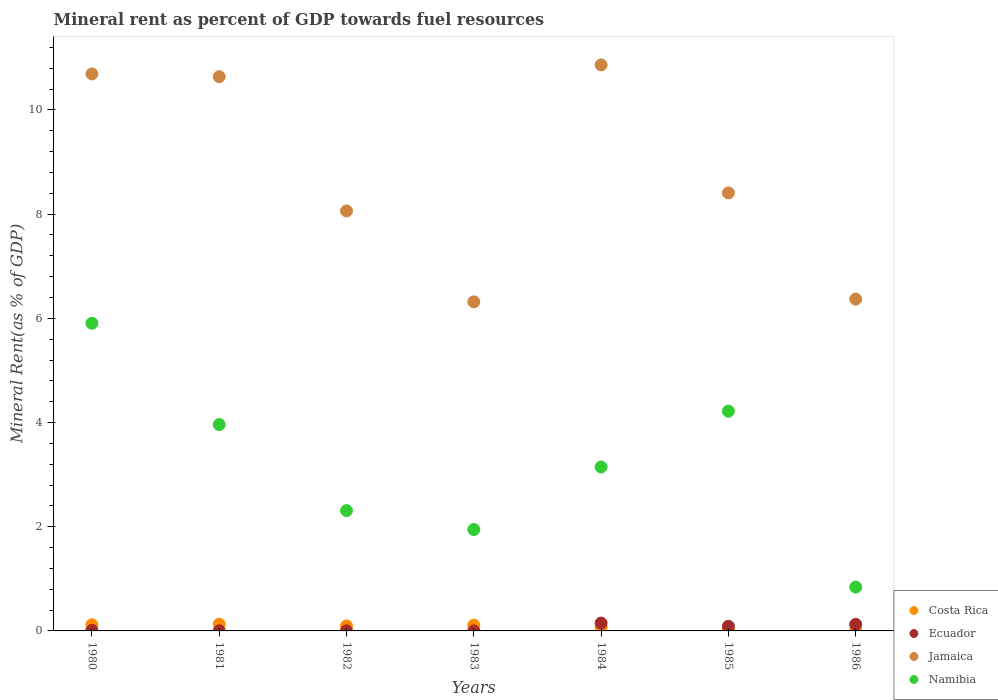Is the number of dotlines equal to the number of legend labels?
Provide a succinct answer. Yes. What is the mineral rent in Jamaica in 1983?
Your answer should be compact. 6.32. Across all years, what is the maximum mineral rent in Jamaica?
Provide a short and direct response. 10.87. Across all years, what is the minimum mineral rent in Namibia?
Keep it short and to the point. 0.84. In which year was the mineral rent in Costa Rica maximum?
Your answer should be very brief. 1981. In which year was the mineral rent in Costa Rica minimum?
Provide a short and direct response. 1985. What is the total mineral rent in Costa Rica in the graph?
Provide a short and direct response. 0.57. What is the difference between the mineral rent in Costa Rica in 1982 and that in 1984?
Provide a succinct answer. 0.03. What is the difference between the mineral rent in Jamaica in 1984 and the mineral rent in Costa Rica in 1982?
Provide a succinct answer. 10.77. What is the average mineral rent in Costa Rica per year?
Your answer should be very brief. 0.08. In the year 1986, what is the difference between the mineral rent in Namibia and mineral rent in Jamaica?
Provide a short and direct response. -5.53. What is the ratio of the mineral rent in Costa Rica in 1980 to that in 1985?
Your answer should be compact. 6.76. Is the mineral rent in Costa Rica in 1980 less than that in 1982?
Provide a succinct answer. No. What is the difference between the highest and the second highest mineral rent in Jamaica?
Your answer should be very brief. 0.17. What is the difference between the highest and the lowest mineral rent in Jamaica?
Your response must be concise. 4.55. In how many years, is the mineral rent in Jamaica greater than the average mineral rent in Jamaica taken over all years?
Your answer should be compact. 3. Is the mineral rent in Ecuador strictly greater than the mineral rent in Namibia over the years?
Give a very brief answer. No. Is the mineral rent in Namibia strictly less than the mineral rent in Costa Rica over the years?
Your answer should be compact. No. What is the difference between two consecutive major ticks on the Y-axis?
Make the answer very short. 2. Are the values on the major ticks of Y-axis written in scientific E-notation?
Give a very brief answer. No. Does the graph contain any zero values?
Offer a terse response. No. Does the graph contain grids?
Offer a very short reply. No. Where does the legend appear in the graph?
Your answer should be compact. Bottom right. How many legend labels are there?
Your answer should be very brief. 4. What is the title of the graph?
Offer a terse response. Mineral rent as percent of GDP towards fuel resources. Does "Togo" appear as one of the legend labels in the graph?
Make the answer very short. No. What is the label or title of the X-axis?
Ensure brevity in your answer.  Years. What is the label or title of the Y-axis?
Your response must be concise. Mineral Rent(as % of GDP). What is the Mineral Rent(as % of GDP) in Costa Rica in 1980?
Ensure brevity in your answer.  0.12. What is the Mineral Rent(as % of GDP) of Ecuador in 1980?
Provide a succinct answer. 0.01. What is the Mineral Rent(as % of GDP) of Jamaica in 1980?
Make the answer very short. 10.69. What is the Mineral Rent(as % of GDP) of Namibia in 1980?
Make the answer very short. 5.91. What is the Mineral Rent(as % of GDP) in Costa Rica in 1981?
Provide a succinct answer. 0.13. What is the Mineral Rent(as % of GDP) in Ecuador in 1981?
Give a very brief answer. 0. What is the Mineral Rent(as % of GDP) of Jamaica in 1981?
Your response must be concise. 10.64. What is the Mineral Rent(as % of GDP) of Namibia in 1981?
Give a very brief answer. 3.96. What is the Mineral Rent(as % of GDP) of Costa Rica in 1982?
Provide a succinct answer. 0.1. What is the Mineral Rent(as % of GDP) of Ecuador in 1982?
Provide a succinct answer. 0. What is the Mineral Rent(as % of GDP) in Jamaica in 1982?
Give a very brief answer. 8.06. What is the Mineral Rent(as % of GDP) in Namibia in 1982?
Ensure brevity in your answer.  2.31. What is the Mineral Rent(as % of GDP) of Costa Rica in 1983?
Your response must be concise. 0.11. What is the Mineral Rent(as % of GDP) of Ecuador in 1983?
Provide a succinct answer. 0. What is the Mineral Rent(as % of GDP) in Jamaica in 1983?
Ensure brevity in your answer.  6.32. What is the Mineral Rent(as % of GDP) of Namibia in 1983?
Ensure brevity in your answer.  1.95. What is the Mineral Rent(as % of GDP) in Costa Rica in 1984?
Keep it short and to the point. 0.07. What is the Mineral Rent(as % of GDP) in Ecuador in 1984?
Your answer should be compact. 0.15. What is the Mineral Rent(as % of GDP) in Jamaica in 1984?
Provide a succinct answer. 10.87. What is the Mineral Rent(as % of GDP) of Namibia in 1984?
Ensure brevity in your answer.  3.15. What is the Mineral Rent(as % of GDP) of Costa Rica in 1985?
Ensure brevity in your answer.  0.02. What is the Mineral Rent(as % of GDP) of Ecuador in 1985?
Provide a succinct answer. 0.09. What is the Mineral Rent(as % of GDP) in Jamaica in 1985?
Your answer should be compact. 8.41. What is the Mineral Rent(as % of GDP) in Namibia in 1985?
Give a very brief answer. 4.22. What is the Mineral Rent(as % of GDP) of Costa Rica in 1986?
Provide a short and direct response. 0.03. What is the Mineral Rent(as % of GDP) in Ecuador in 1986?
Provide a succinct answer. 0.13. What is the Mineral Rent(as % of GDP) of Jamaica in 1986?
Offer a very short reply. 6.37. What is the Mineral Rent(as % of GDP) of Namibia in 1986?
Make the answer very short. 0.84. Across all years, what is the maximum Mineral Rent(as % of GDP) in Costa Rica?
Provide a short and direct response. 0.13. Across all years, what is the maximum Mineral Rent(as % of GDP) of Ecuador?
Offer a terse response. 0.15. Across all years, what is the maximum Mineral Rent(as % of GDP) of Jamaica?
Your response must be concise. 10.87. Across all years, what is the maximum Mineral Rent(as % of GDP) of Namibia?
Provide a short and direct response. 5.91. Across all years, what is the minimum Mineral Rent(as % of GDP) in Costa Rica?
Your answer should be very brief. 0.02. Across all years, what is the minimum Mineral Rent(as % of GDP) in Ecuador?
Your answer should be very brief. 0. Across all years, what is the minimum Mineral Rent(as % of GDP) of Jamaica?
Your response must be concise. 6.32. Across all years, what is the minimum Mineral Rent(as % of GDP) in Namibia?
Make the answer very short. 0.84. What is the total Mineral Rent(as % of GDP) of Costa Rica in the graph?
Your answer should be very brief. 0.57. What is the total Mineral Rent(as % of GDP) of Ecuador in the graph?
Provide a succinct answer. 0.38. What is the total Mineral Rent(as % of GDP) in Jamaica in the graph?
Your answer should be compact. 61.35. What is the total Mineral Rent(as % of GDP) in Namibia in the graph?
Ensure brevity in your answer.  22.33. What is the difference between the Mineral Rent(as % of GDP) of Costa Rica in 1980 and that in 1981?
Make the answer very short. -0.01. What is the difference between the Mineral Rent(as % of GDP) in Ecuador in 1980 and that in 1981?
Provide a short and direct response. 0.01. What is the difference between the Mineral Rent(as % of GDP) in Jamaica in 1980 and that in 1981?
Provide a succinct answer. 0.05. What is the difference between the Mineral Rent(as % of GDP) of Namibia in 1980 and that in 1981?
Keep it short and to the point. 1.94. What is the difference between the Mineral Rent(as % of GDP) in Costa Rica in 1980 and that in 1982?
Your response must be concise. 0.02. What is the difference between the Mineral Rent(as % of GDP) in Ecuador in 1980 and that in 1982?
Your answer should be very brief. 0.01. What is the difference between the Mineral Rent(as % of GDP) of Jamaica in 1980 and that in 1982?
Make the answer very short. 2.63. What is the difference between the Mineral Rent(as % of GDP) of Namibia in 1980 and that in 1982?
Make the answer very short. 3.6. What is the difference between the Mineral Rent(as % of GDP) in Costa Rica in 1980 and that in 1983?
Your answer should be very brief. 0.01. What is the difference between the Mineral Rent(as % of GDP) of Ecuador in 1980 and that in 1983?
Offer a terse response. 0.01. What is the difference between the Mineral Rent(as % of GDP) of Jamaica in 1980 and that in 1983?
Provide a succinct answer. 4.37. What is the difference between the Mineral Rent(as % of GDP) of Namibia in 1980 and that in 1983?
Your answer should be very brief. 3.96. What is the difference between the Mineral Rent(as % of GDP) in Costa Rica in 1980 and that in 1984?
Provide a short and direct response. 0.05. What is the difference between the Mineral Rent(as % of GDP) of Ecuador in 1980 and that in 1984?
Your answer should be very brief. -0.14. What is the difference between the Mineral Rent(as % of GDP) in Jamaica in 1980 and that in 1984?
Provide a succinct answer. -0.17. What is the difference between the Mineral Rent(as % of GDP) in Namibia in 1980 and that in 1984?
Your answer should be very brief. 2.76. What is the difference between the Mineral Rent(as % of GDP) in Costa Rica in 1980 and that in 1985?
Your response must be concise. 0.1. What is the difference between the Mineral Rent(as % of GDP) in Ecuador in 1980 and that in 1985?
Your answer should be compact. -0.08. What is the difference between the Mineral Rent(as % of GDP) of Jamaica in 1980 and that in 1985?
Make the answer very short. 2.28. What is the difference between the Mineral Rent(as % of GDP) in Namibia in 1980 and that in 1985?
Ensure brevity in your answer.  1.69. What is the difference between the Mineral Rent(as % of GDP) in Costa Rica in 1980 and that in 1986?
Provide a succinct answer. 0.09. What is the difference between the Mineral Rent(as % of GDP) of Ecuador in 1980 and that in 1986?
Offer a very short reply. -0.11. What is the difference between the Mineral Rent(as % of GDP) of Jamaica in 1980 and that in 1986?
Your answer should be compact. 4.32. What is the difference between the Mineral Rent(as % of GDP) in Namibia in 1980 and that in 1986?
Provide a succinct answer. 5.06. What is the difference between the Mineral Rent(as % of GDP) of Costa Rica in 1981 and that in 1982?
Your answer should be compact. 0.03. What is the difference between the Mineral Rent(as % of GDP) in Ecuador in 1981 and that in 1982?
Keep it short and to the point. 0. What is the difference between the Mineral Rent(as % of GDP) of Jamaica in 1981 and that in 1982?
Offer a very short reply. 2.58. What is the difference between the Mineral Rent(as % of GDP) in Namibia in 1981 and that in 1982?
Give a very brief answer. 1.65. What is the difference between the Mineral Rent(as % of GDP) of Costa Rica in 1981 and that in 1983?
Provide a short and direct response. 0.02. What is the difference between the Mineral Rent(as % of GDP) of Ecuador in 1981 and that in 1983?
Your response must be concise. 0. What is the difference between the Mineral Rent(as % of GDP) in Jamaica in 1981 and that in 1983?
Ensure brevity in your answer.  4.32. What is the difference between the Mineral Rent(as % of GDP) in Namibia in 1981 and that in 1983?
Your answer should be very brief. 2.02. What is the difference between the Mineral Rent(as % of GDP) of Costa Rica in 1981 and that in 1984?
Your answer should be very brief. 0.06. What is the difference between the Mineral Rent(as % of GDP) of Ecuador in 1981 and that in 1984?
Ensure brevity in your answer.  -0.15. What is the difference between the Mineral Rent(as % of GDP) in Jamaica in 1981 and that in 1984?
Offer a very short reply. -0.23. What is the difference between the Mineral Rent(as % of GDP) of Namibia in 1981 and that in 1984?
Provide a short and direct response. 0.81. What is the difference between the Mineral Rent(as % of GDP) of Costa Rica in 1981 and that in 1985?
Offer a terse response. 0.11. What is the difference between the Mineral Rent(as % of GDP) of Ecuador in 1981 and that in 1985?
Give a very brief answer. -0.09. What is the difference between the Mineral Rent(as % of GDP) in Jamaica in 1981 and that in 1985?
Your answer should be compact. 2.23. What is the difference between the Mineral Rent(as % of GDP) in Namibia in 1981 and that in 1985?
Provide a succinct answer. -0.26. What is the difference between the Mineral Rent(as % of GDP) in Costa Rica in 1981 and that in 1986?
Provide a short and direct response. 0.1. What is the difference between the Mineral Rent(as % of GDP) of Ecuador in 1981 and that in 1986?
Your answer should be compact. -0.12. What is the difference between the Mineral Rent(as % of GDP) of Jamaica in 1981 and that in 1986?
Make the answer very short. 4.27. What is the difference between the Mineral Rent(as % of GDP) in Namibia in 1981 and that in 1986?
Give a very brief answer. 3.12. What is the difference between the Mineral Rent(as % of GDP) in Costa Rica in 1982 and that in 1983?
Keep it short and to the point. -0.01. What is the difference between the Mineral Rent(as % of GDP) in Jamaica in 1982 and that in 1983?
Your answer should be very brief. 1.75. What is the difference between the Mineral Rent(as % of GDP) of Namibia in 1982 and that in 1983?
Provide a succinct answer. 0.36. What is the difference between the Mineral Rent(as % of GDP) of Costa Rica in 1982 and that in 1984?
Make the answer very short. 0.03. What is the difference between the Mineral Rent(as % of GDP) in Ecuador in 1982 and that in 1984?
Provide a succinct answer. -0.15. What is the difference between the Mineral Rent(as % of GDP) of Jamaica in 1982 and that in 1984?
Offer a very short reply. -2.8. What is the difference between the Mineral Rent(as % of GDP) of Namibia in 1982 and that in 1984?
Your response must be concise. -0.84. What is the difference between the Mineral Rent(as % of GDP) in Ecuador in 1982 and that in 1985?
Provide a succinct answer. -0.09. What is the difference between the Mineral Rent(as % of GDP) in Jamaica in 1982 and that in 1985?
Your answer should be compact. -0.35. What is the difference between the Mineral Rent(as % of GDP) in Namibia in 1982 and that in 1985?
Make the answer very short. -1.91. What is the difference between the Mineral Rent(as % of GDP) of Costa Rica in 1982 and that in 1986?
Provide a short and direct response. 0.07. What is the difference between the Mineral Rent(as % of GDP) of Ecuador in 1982 and that in 1986?
Keep it short and to the point. -0.12. What is the difference between the Mineral Rent(as % of GDP) of Jamaica in 1982 and that in 1986?
Your response must be concise. 1.69. What is the difference between the Mineral Rent(as % of GDP) of Namibia in 1982 and that in 1986?
Your response must be concise. 1.47. What is the difference between the Mineral Rent(as % of GDP) of Costa Rica in 1983 and that in 1984?
Keep it short and to the point. 0.04. What is the difference between the Mineral Rent(as % of GDP) of Ecuador in 1983 and that in 1984?
Give a very brief answer. -0.15. What is the difference between the Mineral Rent(as % of GDP) of Jamaica in 1983 and that in 1984?
Offer a terse response. -4.55. What is the difference between the Mineral Rent(as % of GDP) in Namibia in 1983 and that in 1984?
Give a very brief answer. -1.2. What is the difference between the Mineral Rent(as % of GDP) of Costa Rica in 1983 and that in 1985?
Provide a succinct answer. 0.09. What is the difference between the Mineral Rent(as % of GDP) in Ecuador in 1983 and that in 1985?
Your response must be concise. -0.09. What is the difference between the Mineral Rent(as % of GDP) in Jamaica in 1983 and that in 1985?
Give a very brief answer. -2.09. What is the difference between the Mineral Rent(as % of GDP) of Namibia in 1983 and that in 1985?
Your response must be concise. -2.27. What is the difference between the Mineral Rent(as % of GDP) in Costa Rica in 1983 and that in 1986?
Provide a short and direct response. 0.09. What is the difference between the Mineral Rent(as % of GDP) in Ecuador in 1983 and that in 1986?
Your answer should be very brief. -0.13. What is the difference between the Mineral Rent(as % of GDP) of Jamaica in 1983 and that in 1986?
Provide a short and direct response. -0.05. What is the difference between the Mineral Rent(as % of GDP) in Namibia in 1983 and that in 1986?
Your response must be concise. 1.1. What is the difference between the Mineral Rent(as % of GDP) in Costa Rica in 1984 and that in 1985?
Provide a short and direct response. 0.05. What is the difference between the Mineral Rent(as % of GDP) in Ecuador in 1984 and that in 1985?
Give a very brief answer. 0.06. What is the difference between the Mineral Rent(as % of GDP) in Jamaica in 1984 and that in 1985?
Offer a terse response. 2.46. What is the difference between the Mineral Rent(as % of GDP) in Namibia in 1984 and that in 1985?
Your answer should be compact. -1.07. What is the difference between the Mineral Rent(as % of GDP) of Costa Rica in 1984 and that in 1986?
Provide a succinct answer. 0.04. What is the difference between the Mineral Rent(as % of GDP) in Ecuador in 1984 and that in 1986?
Ensure brevity in your answer.  0.02. What is the difference between the Mineral Rent(as % of GDP) of Jamaica in 1984 and that in 1986?
Offer a terse response. 4.5. What is the difference between the Mineral Rent(as % of GDP) of Namibia in 1984 and that in 1986?
Offer a very short reply. 2.31. What is the difference between the Mineral Rent(as % of GDP) in Costa Rica in 1985 and that in 1986?
Your answer should be very brief. -0.01. What is the difference between the Mineral Rent(as % of GDP) of Ecuador in 1985 and that in 1986?
Make the answer very short. -0.04. What is the difference between the Mineral Rent(as % of GDP) of Jamaica in 1985 and that in 1986?
Keep it short and to the point. 2.04. What is the difference between the Mineral Rent(as % of GDP) of Namibia in 1985 and that in 1986?
Ensure brevity in your answer.  3.38. What is the difference between the Mineral Rent(as % of GDP) of Costa Rica in 1980 and the Mineral Rent(as % of GDP) of Ecuador in 1981?
Offer a very short reply. 0.12. What is the difference between the Mineral Rent(as % of GDP) in Costa Rica in 1980 and the Mineral Rent(as % of GDP) in Jamaica in 1981?
Make the answer very short. -10.52. What is the difference between the Mineral Rent(as % of GDP) in Costa Rica in 1980 and the Mineral Rent(as % of GDP) in Namibia in 1981?
Provide a succinct answer. -3.84. What is the difference between the Mineral Rent(as % of GDP) of Ecuador in 1980 and the Mineral Rent(as % of GDP) of Jamaica in 1981?
Make the answer very short. -10.63. What is the difference between the Mineral Rent(as % of GDP) in Ecuador in 1980 and the Mineral Rent(as % of GDP) in Namibia in 1981?
Your answer should be compact. -3.95. What is the difference between the Mineral Rent(as % of GDP) of Jamaica in 1980 and the Mineral Rent(as % of GDP) of Namibia in 1981?
Keep it short and to the point. 6.73. What is the difference between the Mineral Rent(as % of GDP) of Costa Rica in 1980 and the Mineral Rent(as % of GDP) of Ecuador in 1982?
Give a very brief answer. 0.12. What is the difference between the Mineral Rent(as % of GDP) in Costa Rica in 1980 and the Mineral Rent(as % of GDP) in Jamaica in 1982?
Offer a very short reply. -7.94. What is the difference between the Mineral Rent(as % of GDP) of Costa Rica in 1980 and the Mineral Rent(as % of GDP) of Namibia in 1982?
Provide a short and direct response. -2.19. What is the difference between the Mineral Rent(as % of GDP) of Ecuador in 1980 and the Mineral Rent(as % of GDP) of Jamaica in 1982?
Offer a very short reply. -8.05. What is the difference between the Mineral Rent(as % of GDP) of Ecuador in 1980 and the Mineral Rent(as % of GDP) of Namibia in 1982?
Ensure brevity in your answer.  -2.3. What is the difference between the Mineral Rent(as % of GDP) of Jamaica in 1980 and the Mineral Rent(as % of GDP) of Namibia in 1982?
Your answer should be compact. 8.38. What is the difference between the Mineral Rent(as % of GDP) of Costa Rica in 1980 and the Mineral Rent(as % of GDP) of Ecuador in 1983?
Provide a short and direct response. 0.12. What is the difference between the Mineral Rent(as % of GDP) in Costa Rica in 1980 and the Mineral Rent(as % of GDP) in Jamaica in 1983?
Make the answer very short. -6.2. What is the difference between the Mineral Rent(as % of GDP) of Costa Rica in 1980 and the Mineral Rent(as % of GDP) of Namibia in 1983?
Give a very brief answer. -1.83. What is the difference between the Mineral Rent(as % of GDP) of Ecuador in 1980 and the Mineral Rent(as % of GDP) of Jamaica in 1983?
Give a very brief answer. -6.31. What is the difference between the Mineral Rent(as % of GDP) in Ecuador in 1980 and the Mineral Rent(as % of GDP) in Namibia in 1983?
Give a very brief answer. -1.93. What is the difference between the Mineral Rent(as % of GDP) of Jamaica in 1980 and the Mineral Rent(as % of GDP) of Namibia in 1983?
Provide a succinct answer. 8.75. What is the difference between the Mineral Rent(as % of GDP) in Costa Rica in 1980 and the Mineral Rent(as % of GDP) in Ecuador in 1984?
Offer a terse response. -0.03. What is the difference between the Mineral Rent(as % of GDP) in Costa Rica in 1980 and the Mineral Rent(as % of GDP) in Jamaica in 1984?
Provide a succinct answer. -10.75. What is the difference between the Mineral Rent(as % of GDP) in Costa Rica in 1980 and the Mineral Rent(as % of GDP) in Namibia in 1984?
Offer a terse response. -3.03. What is the difference between the Mineral Rent(as % of GDP) in Ecuador in 1980 and the Mineral Rent(as % of GDP) in Jamaica in 1984?
Ensure brevity in your answer.  -10.85. What is the difference between the Mineral Rent(as % of GDP) of Ecuador in 1980 and the Mineral Rent(as % of GDP) of Namibia in 1984?
Make the answer very short. -3.14. What is the difference between the Mineral Rent(as % of GDP) of Jamaica in 1980 and the Mineral Rent(as % of GDP) of Namibia in 1984?
Give a very brief answer. 7.54. What is the difference between the Mineral Rent(as % of GDP) of Costa Rica in 1980 and the Mineral Rent(as % of GDP) of Ecuador in 1985?
Offer a very short reply. 0.03. What is the difference between the Mineral Rent(as % of GDP) of Costa Rica in 1980 and the Mineral Rent(as % of GDP) of Jamaica in 1985?
Your answer should be very brief. -8.29. What is the difference between the Mineral Rent(as % of GDP) of Costa Rica in 1980 and the Mineral Rent(as % of GDP) of Namibia in 1985?
Offer a very short reply. -4.1. What is the difference between the Mineral Rent(as % of GDP) in Ecuador in 1980 and the Mineral Rent(as % of GDP) in Jamaica in 1985?
Provide a succinct answer. -8.4. What is the difference between the Mineral Rent(as % of GDP) of Ecuador in 1980 and the Mineral Rent(as % of GDP) of Namibia in 1985?
Provide a succinct answer. -4.21. What is the difference between the Mineral Rent(as % of GDP) in Jamaica in 1980 and the Mineral Rent(as % of GDP) in Namibia in 1985?
Your answer should be very brief. 6.47. What is the difference between the Mineral Rent(as % of GDP) of Costa Rica in 1980 and the Mineral Rent(as % of GDP) of Ecuador in 1986?
Ensure brevity in your answer.  -0.01. What is the difference between the Mineral Rent(as % of GDP) of Costa Rica in 1980 and the Mineral Rent(as % of GDP) of Jamaica in 1986?
Give a very brief answer. -6.25. What is the difference between the Mineral Rent(as % of GDP) in Costa Rica in 1980 and the Mineral Rent(as % of GDP) in Namibia in 1986?
Your response must be concise. -0.72. What is the difference between the Mineral Rent(as % of GDP) of Ecuador in 1980 and the Mineral Rent(as % of GDP) of Jamaica in 1986?
Provide a succinct answer. -6.36. What is the difference between the Mineral Rent(as % of GDP) in Ecuador in 1980 and the Mineral Rent(as % of GDP) in Namibia in 1986?
Keep it short and to the point. -0.83. What is the difference between the Mineral Rent(as % of GDP) of Jamaica in 1980 and the Mineral Rent(as % of GDP) of Namibia in 1986?
Provide a succinct answer. 9.85. What is the difference between the Mineral Rent(as % of GDP) of Costa Rica in 1981 and the Mineral Rent(as % of GDP) of Ecuador in 1982?
Provide a succinct answer. 0.13. What is the difference between the Mineral Rent(as % of GDP) in Costa Rica in 1981 and the Mineral Rent(as % of GDP) in Jamaica in 1982?
Ensure brevity in your answer.  -7.93. What is the difference between the Mineral Rent(as % of GDP) of Costa Rica in 1981 and the Mineral Rent(as % of GDP) of Namibia in 1982?
Provide a succinct answer. -2.18. What is the difference between the Mineral Rent(as % of GDP) of Ecuador in 1981 and the Mineral Rent(as % of GDP) of Jamaica in 1982?
Keep it short and to the point. -8.06. What is the difference between the Mineral Rent(as % of GDP) in Ecuador in 1981 and the Mineral Rent(as % of GDP) in Namibia in 1982?
Your answer should be compact. -2.31. What is the difference between the Mineral Rent(as % of GDP) in Jamaica in 1981 and the Mineral Rent(as % of GDP) in Namibia in 1982?
Offer a very short reply. 8.33. What is the difference between the Mineral Rent(as % of GDP) in Costa Rica in 1981 and the Mineral Rent(as % of GDP) in Ecuador in 1983?
Provide a succinct answer. 0.13. What is the difference between the Mineral Rent(as % of GDP) in Costa Rica in 1981 and the Mineral Rent(as % of GDP) in Jamaica in 1983?
Your answer should be compact. -6.19. What is the difference between the Mineral Rent(as % of GDP) of Costa Rica in 1981 and the Mineral Rent(as % of GDP) of Namibia in 1983?
Make the answer very short. -1.82. What is the difference between the Mineral Rent(as % of GDP) of Ecuador in 1981 and the Mineral Rent(as % of GDP) of Jamaica in 1983?
Provide a succinct answer. -6.31. What is the difference between the Mineral Rent(as % of GDP) in Ecuador in 1981 and the Mineral Rent(as % of GDP) in Namibia in 1983?
Offer a terse response. -1.94. What is the difference between the Mineral Rent(as % of GDP) in Jamaica in 1981 and the Mineral Rent(as % of GDP) in Namibia in 1983?
Offer a very short reply. 8.69. What is the difference between the Mineral Rent(as % of GDP) in Costa Rica in 1981 and the Mineral Rent(as % of GDP) in Ecuador in 1984?
Make the answer very short. -0.02. What is the difference between the Mineral Rent(as % of GDP) in Costa Rica in 1981 and the Mineral Rent(as % of GDP) in Jamaica in 1984?
Offer a terse response. -10.74. What is the difference between the Mineral Rent(as % of GDP) in Costa Rica in 1981 and the Mineral Rent(as % of GDP) in Namibia in 1984?
Give a very brief answer. -3.02. What is the difference between the Mineral Rent(as % of GDP) of Ecuador in 1981 and the Mineral Rent(as % of GDP) of Jamaica in 1984?
Provide a short and direct response. -10.86. What is the difference between the Mineral Rent(as % of GDP) in Ecuador in 1981 and the Mineral Rent(as % of GDP) in Namibia in 1984?
Provide a short and direct response. -3.14. What is the difference between the Mineral Rent(as % of GDP) in Jamaica in 1981 and the Mineral Rent(as % of GDP) in Namibia in 1984?
Give a very brief answer. 7.49. What is the difference between the Mineral Rent(as % of GDP) of Costa Rica in 1981 and the Mineral Rent(as % of GDP) of Ecuador in 1985?
Offer a very short reply. 0.04. What is the difference between the Mineral Rent(as % of GDP) in Costa Rica in 1981 and the Mineral Rent(as % of GDP) in Jamaica in 1985?
Ensure brevity in your answer.  -8.28. What is the difference between the Mineral Rent(as % of GDP) of Costa Rica in 1981 and the Mineral Rent(as % of GDP) of Namibia in 1985?
Provide a succinct answer. -4.09. What is the difference between the Mineral Rent(as % of GDP) in Ecuador in 1981 and the Mineral Rent(as % of GDP) in Jamaica in 1985?
Offer a terse response. -8.4. What is the difference between the Mineral Rent(as % of GDP) in Ecuador in 1981 and the Mineral Rent(as % of GDP) in Namibia in 1985?
Make the answer very short. -4.21. What is the difference between the Mineral Rent(as % of GDP) of Jamaica in 1981 and the Mineral Rent(as % of GDP) of Namibia in 1985?
Keep it short and to the point. 6.42. What is the difference between the Mineral Rent(as % of GDP) in Costa Rica in 1981 and the Mineral Rent(as % of GDP) in Ecuador in 1986?
Provide a short and direct response. 0. What is the difference between the Mineral Rent(as % of GDP) in Costa Rica in 1981 and the Mineral Rent(as % of GDP) in Jamaica in 1986?
Make the answer very short. -6.24. What is the difference between the Mineral Rent(as % of GDP) in Costa Rica in 1981 and the Mineral Rent(as % of GDP) in Namibia in 1986?
Give a very brief answer. -0.71. What is the difference between the Mineral Rent(as % of GDP) of Ecuador in 1981 and the Mineral Rent(as % of GDP) of Jamaica in 1986?
Provide a succinct answer. -6.37. What is the difference between the Mineral Rent(as % of GDP) of Ecuador in 1981 and the Mineral Rent(as % of GDP) of Namibia in 1986?
Offer a terse response. -0.84. What is the difference between the Mineral Rent(as % of GDP) in Jamaica in 1981 and the Mineral Rent(as % of GDP) in Namibia in 1986?
Give a very brief answer. 9.8. What is the difference between the Mineral Rent(as % of GDP) in Costa Rica in 1982 and the Mineral Rent(as % of GDP) in Ecuador in 1983?
Provide a short and direct response. 0.1. What is the difference between the Mineral Rent(as % of GDP) in Costa Rica in 1982 and the Mineral Rent(as % of GDP) in Jamaica in 1983?
Give a very brief answer. -6.22. What is the difference between the Mineral Rent(as % of GDP) of Costa Rica in 1982 and the Mineral Rent(as % of GDP) of Namibia in 1983?
Your answer should be compact. -1.85. What is the difference between the Mineral Rent(as % of GDP) in Ecuador in 1982 and the Mineral Rent(as % of GDP) in Jamaica in 1983?
Make the answer very short. -6.32. What is the difference between the Mineral Rent(as % of GDP) in Ecuador in 1982 and the Mineral Rent(as % of GDP) in Namibia in 1983?
Your response must be concise. -1.94. What is the difference between the Mineral Rent(as % of GDP) in Jamaica in 1982 and the Mineral Rent(as % of GDP) in Namibia in 1983?
Give a very brief answer. 6.12. What is the difference between the Mineral Rent(as % of GDP) of Costa Rica in 1982 and the Mineral Rent(as % of GDP) of Ecuador in 1984?
Keep it short and to the point. -0.05. What is the difference between the Mineral Rent(as % of GDP) in Costa Rica in 1982 and the Mineral Rent(as % of GDP) in Jamaica in 1984?
Provide a short and direct response. -10.77. What is the difference between the Mineral Rent(as % of GDP) in Costa Rica in 1982 and the Mineral Rent(as % of GDP) in Namibia in 1984?
Make the answer very short. -3.05. What is the difference between the Mineral Rent(as % of GDP) in Ecuador in 1982 and the Mineral Rent(as % of GDP) in Jamaica in 1984?
Provide a succinct answer. -10.86. What is the difference between the Mineral Rent(as % of GDP) of Ecuador in 1982 and the Mineral Rent(as % of GDP) of Namibia in 1984?
Your response must be concise. -3.15. What is the difference between the Mineral Rent(as % of GDP) of Jamaica in 1982 and the Mineral Rent(as % of GDP) of Namibia in 1984?
Provide a short and direct response. 4.92. What is the difference between the Mineral Rent(as % of GDP) of Costa Rica in 1982 and the Mineral Rent(as % of GDP) of Ecuador in 1985?
Offer a terse response. 0.01. What is the difference between the Mineral Rent(as % of GDP) in Costa Rica in 1982 and the Mineral Rent(as % of GDP) in Jamaica in 1985?
Your response must be concise. -8.31. What is the difference between the Mineral Rent(as % of GDP) in Costa Rica in 1982 and the Mineral Rent(as % of GDP) in Namibia in 1985?
Provide a succinct answer. -4.12. What is the difference between the Mineral Rent(as % of GDP) in Ecuador in 1982 and the Mineral Rent(as % of GDP) in Jamaica in 1985?
Provide a short and direct response. -8.41. What is the difference between the Mineral Rent(as % of GDP) in Ecuador in 1982 and the Mineral Rent(as % of GDP) in Namibia in 1985?
Your answer should be very brief. -4.22. What is the difference between the Mineral Rent(as % of GDP) in Jamaica in 1982 and the Mineral Rent(as % of GDP) in Namibia in 1985?
Offer a terse response. 3.84. What is the difference between the Mineral Rent(as % of GDP) in Costa Rica in 1982 and the Mineral Rent(as % of GDP) in Ecuador in 1986?
Provide a short and direct response. -0.03. What is the difference between the Mineral Rent(as % of GDP) in Costa Rica in 1982 and the Mineral Rent(as % of GDP) in Jamaica in 1986?
Offer a terse response. -6.27. What is the difference between the Mineral Rent(as % of GDP) in Costa Rica in 1982 and the Mineral Rent(as % of GDP) in Namibia in 1986?
Provide a succinct answer. -0.74. What is the difference between the Mineral Rent(as % of GDP) of Ecuador in 1982 and the Mineral Rent(as % of GDP) of Jamaica in 1986?
Your response must be concise. -6.37. What is the difference between the Mineral Rent(as % of GDP) in Ecuador in 1982 and the Mineral Rent(as % of GDP) in Namibia in 1986?
Provide a succinct answer. -0.84. What is the difference between the Mineral Rent(as % of GDP) of Jamaica in 1982 and the Mineral Rent(as % of GDP) of Namibia in 1986?
Give a very brief answer. 7.22. What is the difference between the Mineral Rent(as % of GDP) in Costa Rica in 1983 and the Mineral Rent(as % of GDP) in Ecuador in 1984?
Keep it short and to the point. -0.04. What is the difference between the Mineral Rent(as % of GDP) of Costa Rica in 1983 and the Mineral Rent(as % of GDP) of Jamaica in 1984?
Offer a terse response. -10.75. What is the difference between the Mineral Rent(as % of GDP) in Costa Rica in 1983 and the Mineral Rent(as % of GDP) in Namibia in 1984?
Provide a short and direct response. -3.03. What is the difference between the Mineral Rent(as % of GDP) in Ecuador in 1983 and the Mineral Rent(as % of GDP) in Jamaica in 1984?
Provide a succinct answer. -10.86. What is the difference between the Mineral Rent(as % of GDP) of Ecuador in 1983 and the Mineral Rent(as % of GDP) of Namibia in 1984?
Make the answer very short. -3.15. What is the difference between the Mineral Rent(as % of GDP) of Jamaica in 1983 and the Mineral Rent(as % of GDP) of Namibia in 1984?
Provide a short and direct response. 3.17. What is the difference between the Mineral Rent(as % of GDP) of Costa Rica in 1983 and the Mineral Rent(as % of GDP) of Ecuador in 1985?
Provide a short and direct response. 0.02. What is the difference between the Mineral Rent(as % of GDP) in Costa Rica in 1983 and the Mineral Rent(as % of GDP) in Jamaica in 1985?
Provide a succinct answer. -8.3. What is the difference between the Mineral Rent(as % of GDP) in Costa Rica in 1983 and the Mineral Rent(as % of GDP) in Namibia in 1985?
Offer a terse response. -4.11. What is the difference between the Mineral Rent(as % of GDP) in Ecuador in 1983 and the Mineral Rent(as % of GDP) in Jamaica in 1985?
Your answer should be very brief. -8.41. What is the difference between the Mineral Rent(as % of GDP) of Ecuador in 1983 and the Mineral Rent(as % of GDP) of Namibia in 1985?
Give a very brief answer. -4.22. What is the difference between the Mineral Rent(as % of GDP) of Jamaica in 1983 and the Mineral Rent(as % of GDP) of Namibia in 1985?
Give a very brief answer. 2.1. What is the difference between the Mineral Rent(as % of GDP) in Costa Rica in 1983 and the Mineral Rent(as % of GDP) in Ecuador in 1986?
Give a very brief answer. -0.01. What is the difference between the Mineral Rent(as % of GDP) in Costa Rica in 1983 and the Mineral Rent(as % of GDP) in Jamaica in 1986?
Your answer should be compact. -6.26. What is the difference between the Mineral Rent(as % of GDP) in Costa Rica in 1983 and the Mineral Rent(as % of GDP) in Namibia in 1986?
Offer a terse response. -0.73. What is the difference between the Mineral Rent(as % of GDP) in Ecuador in 1983 and the Mineral Rent(as % of GDP) in Jamaica in 1986?
Offer a very short reply. -6.37. What is the difference between the Mineral Rent(as % of GDP) of Ecuador in 1983 and the Mineral Rent(as % of GDP) of Namibia in 1986?
Make the answer very short. -0.84. What is the difference between the Mineral Rent(as % of GDP) of Jamaica in 1983 and the Mineral Rent(as % of GDP) of Namibia in 1986?
Provide a succinct answer. 5.48. What is the difference between the Mineral Rent(as % of GDP) of Costa Rica in 1984 and the Mineral Rent(as % of GDP) of Ecuador in 1985?
Offer a terse response. -0.02. What is the difference between the Mineral Rent(as % of GDP) of Costa Rica in 1984 and the Mineral Rent(as % of GDP) of Jamaica in 1985?
Make the answer very short. -8.34. What is the difference between the Mineral Rent(as % of GDP) of Costa Rica in 1984 and the Mineral Rent(as % of GDP) of Namibia in 1985?
Provide a short and direct response. -4.15. What is the difference between the Mineral Rent(as % of GDP) in Ecuador in 1984 and the Mineral Rent(as % of GDP) in Jamaica in 1985?
Offer a very short reply. -8.26. What is the difference between the Mineral Rent(as % of GDP) in Ecuador in 1984 and the Mineral Rent(as % of GDP) in Namibia in 1985?
Keep it short and to the point. -4.07. What is the difference between the Mineral Rent(as % of GDP) of Jamaica in 1984 and the Mineral Rent(as % of GDP) of Namibia in 1985?
Provide a succinct answer. 6.65. What is the difference between the Mineral Rent(as % of GDP) of Costa Rica in 1984 and the Mineral Rent(as % of GDP) of Ecuador in 1986?
Provide a short and direct response. -0.06. What is the difference between the Mineral Rent(as % of GDP) in Costa Rica in 1984 and the Mineral Rent(as % of GDP) in Jamaica in 1986?
Keep it short and to the point. -6.3. What is the difference between the Mineral Rent(as % of GDP) of Costa Rica in 1984 and the Mineral Rent(as % of GDP) of Namibia in 1986?
Ensure brevity in your answer.  -0.77. What is the difference between the Mineral Rent(as % of GDP) of Ecuador in 1984 and the Mineral Rent(as % of GDP) of Jamaica in 1986?
Make the answer very short. -6.22. What is the difference between the Mineral Rent(as % of GDP) in Ecuador in 1984 and the Mineral Rent(as % of GDP) in Namibia in 1986?
Keep it short and to the point. -0.69. What is the difference between the Mineral Rent(as % of GDP) of Jamaica in 1984 and the Mineral Rent(as % of GDP) of Namibia in 1986?
Offer a very short reply. 10.02. What is the difference between the Mineral Rent(as % of GDP) of Costa Rica in 1985 and the Mineral Rent(as % of GDP) of Ecuador in 1986?
Provide a short and direct response. -0.11. What is the difference between the Mineral Rent(as % of GDP) of Costa Rica in 1985 and the Mineral Rent(as % of GDP) of Jamaica in 1986?
Provide a short and direct response. -6.35. What is the difference between the Mineral Rent(as % of GDP) in Costa Rica in 1985 and the Mineral Rent(as % of GDP) in Namibia in 1986?
Provide a short and direct response. -0.82. What is the difference between the Mineral Rent(as % of GDP) of Ecuador in 1985 and the Mineral Rent(as % of GDP) of Jamaica in 1986?
Your answer should be very brief. -6.28. What is the difference between the Mineral Rent(as % of GDP) in Ecuador in 1985 and the Mineral Rent(as % of GDP) in Namibia in 1986?
Give a very brief answer. -0.75. What is the difference between the Mineral Rent(as % of GDP) in Jamaica in 1985 and the Mineral Rent(as % of GDP) in Namibia in 1986?
Your answer should be compact. 7.57. What is the average Mineral Rent(as % of GDP) in Costa Rica per year?
Offer a terse response. 0.08. What is the average Mineral Rent(as % of GDP) in Ecuador per year?
Provide a succinct answer. 0.05. What is the average Mineral Rent(as % of GDP) of Jamaica per year?
Make the answer very short. 8.76. What is the average Mineral Rent(as % of GDP) of Namibia per year?
Ensure brevity in your answer.  3.19. In the year 1980, what is the difference between the Mineral Rent(as % of GDP) in Costa Rica and Mineral Rent(as % of GDP) in Ecuador?
Offer a terse response. 0.11. In the year 1980, what is the difference between the Mineral Rent(as % of GDP) in Costa Rica and Mineral Rent(as % of GDP) in Jamaica?
Make the answer very short. -10.57. In the year 1980, what is the difference between the Mineral Rent(as % of GDP) of Costa Rica and Mineral Rent(as % of GDP) of Namibia?
Offer a terse response. -5.79. In the year 1980, what is the difference between the Mineral Rent(as % of GDP) of Ecuador and Mineral Rent(as % of GDP) of Jamaica?
Ensure brevity in your answer.  -10.68. In the year 1980, what is the difference between the Mineral Rent(as % of GDP) in Ecuador and Mineral Rent(as % of GDP) in Namibia?
Make the answer very short. -5.89. In the year 1980, what is the difference between the Mineral Rent(as % of GDP) in Jamaica and Mineral Rent(as % of GDP) in Namibia?
Give a very brief answer. 4.79. In the year 1981, what is the difference between the Mineral Rent(as % of GDP) of Costa Rica and Mineral Rent(as % of GDP) of Ecuador?
Provide a succinct answer. 0.13. In the year 1981, what is the difference between the Mineral Rent(as % of GDP) of Costa Rica and Mineral Rent(as % of GDP) of Jamaica?
Ensure brevity in your answer.  -10.51. In the year 1981, what is the difference between the Mineral Rent(as % of GDP) in Costa Rica and Mineral Rent(as % of GDP) in Namibia?
Ensure brevity in your answer.  -3.83. In the year 1981, what is the difference between the Mineral Rent(as % of GDP) in Ecuador and Mineral Rent(as % of GDP) in Jamaica?
Keep it short and to the point. -10.64. In the year 1981, what is the difference between the Mineral Rent(as % of GDP) in Ecuador and Mineral Rent(as % of GDP) in Namibia?
Offer a very short reply. -3.96. In the year 1981, what is the difference between the Mineral Rent(as % of GDP) of Jamaica and Mineral Rent(as % of GDP) of Namibia?
Provide a succinct answer. 6.68. In the year 1982, what is the difference between the Mineral Rent(as % of GDP) in Costa Rica and Mineral Rent(as % of GDP) in Ecuador?
Provide a short and direct response. 0.1. In the year 1982, what is the difference between the Mineral Rent(as % of GDP) of Costa Rica and Mineral Rent(as % of GDP) of Jamaica?
Offer a terse response. -7.96. In the year 1982, what is the difference between the Mineral Rent(as % of GDP) in Costa Rica and Mineral Rent(as % of GDP) in Namibia?
Provide a short and direct response. -2.21. In the year 1982, what is the difference between the Mineral Rent(as % of GDP) in Ecuador and Mineral Rent(as % of GDP) in Jamaica?
Give a very brief answer. -8.06. In the year 1982, what is the difference between the Mineral Rent(as % of GDP) of Ecuador and Mineral Rent(as % of GDP) of Namibia?
Ensure brevity in your answer.  -2.31. In the year 1982, what is the difference between the Mineral Rent(as % of GDP) in Jamaica and Mineral Rent(as % of GDP) in Namibia?
Ensure brevity in your answer.  5.75. In the year 1983, what is the difference between the Mineral Rent(as % of GDP) in Costa Rica and Mineral Rent(as % of GDP) in Ecuador?
Provide a short and direct response. 0.11. In the year 1983, what is the difference between the Mineral Rent(as % of GDP) in Costa Rica and Mineral Rent(as % of GDP) in Jamaica?
Offer a very short reply. -6.2. In the year 1983, what is the difference between the Mineral Rent(as % of GDP) in Costa Rica and Mineral Rent(as % of GDP) in Namibia?
Provide a succinct answer. -1.83. In the year 1983, what is the difference between the Mineral Rent(as % of GDP) in Ecuador and Mineral Rent(as % of GDP) in Jamaica?
Make the answer very short. -6.32. In the year 1983, what is the difference between the Mineral Rent(as % of GDP) of Ecuador and Mineral Rent(as % of GDP) of Namibia?
Offer a very short reply. -1.95. In the year 1983, what is the difference between the Mineral Rent(as % of GDP) in Jamaica and Mineral Rent(as % of GDP) in Namibia?
Make the answer very short. 4.37. In the year 1984, what is the difference between the Mineral Rent(as % of GDP) of Costa Rica and Mineral Rent(as % of GDP) of Ecuador?
Offer a terse response. -0.08. In the year 1984, what is the difference between the Mineral Rent(as % of GDP) of Costa Rica and Mineral Rent(as % of GDP) of Jamaica?
Offer a terse response. -10.79. In the year 1984, what is the difference between the Mineral Rent(as % of GDP) of Costa Rica and Mineral Rent(as % of GDP) of Namibia?
Ensure brevity in your answer.  -3.08. In the year 1984, what is the difference between the Mineral Rent(as % of GDP) in Ecuador and Mineral Rent(as % of GDP) in Jamaica?
Your response must be concise. -10.71. In the year 1984, what is the difference between the Mineral Rent(as % of GDP) in Ecuador and Mineral Rent(as % of GDP) in Namibia?
Your response must be concise. -3. In the year 1984, what is the difference between the Mineral Rent(as % of GDP) in Jamaica and Mineral Rent(as % of GDP) in Namibia?
Give a very brief answer. 7.72. In the year 1985, what is the difference between the Mineral Rent(as % of GDP) in Costa Rica and Mineral Rent(as % of GDP) in Ecuador?
Your answer should be very brief. -0.07. In the year 1985, what is the difference between the Mineral Rent(as % of GDP) of Costa Rica and Mineral Rent(as % of GDP) of Jamaica?
Ensure brevity in your answer.  -8.39. In the year 1985, what is the difference between the Mineral Rent(as % of GDP) of Costa Rica and Mineral Rent(as % of GDP) of Namibia?
Give a very brief answer. -4.2. In the year 1985, what is the difference between the Mineral Rent(as % of GDP) in Ecuador and Mineral Rent(as % of GDP) in Jamaica?
Provide a succinct answer. -8.32. In the year 1985, what is the difference between the Mineral Rent(as % of GDP) of Ecuador and Mineral Rent(as % of GDP) of Namibia?
Offer a very short reply. -4.13. In the year 1985, what is the difference between the Mineral Rent(as % of GDP) of Jamaica and Mineral Rent(as % of GDP) of Namibia?
Ensure brevity in your answer.  4.19. In the year 1986, what is the difference between the Mineral Rent(as % of GDP) of Costa Rica and Mineral Rent(as % of GDP) of Ecuador?
Make the answer very short. -0.1. In the year 1986, what is the difference between the Mineral Rent(as % of GDP) in Costa Rica and Mineral Rent(as % of GDP) in Jamaica?
Ensure brevity in your answer.  -6.34. In the year 1986, what is the difference between the Mineral Rent(as % of GDP) in Costa Rica and Mineral Rent(as % of GDP) in Namibia?
Offer a very short reply. -0.82. In the year 1986, what is the difference between the Mineral Rent(as % of GDP) in Ecuador and Mineral Rent(as % of GDP) in Jamaica?
Keep it short and to the point. -6.24. In the year 1986, what is the difference between the Mineral Rent(as % of GDP) in Ecuador and Mineral Rent(as % of GDP) in Namibia?
Keep it short and to the point. -0.72. In the year 1986, what is the difference between the Mineral Rent(as % of GDP) of Jamaica and Mineral Rent(as % of GDP) of Namibia?
Give a very brief answer. 5.53. What is the ratio of the Mineral Rent(as % of GDP) of Costa Rica in 1980 to that in 1981?
Make the answer very short. 0.92. What is the ratio of the Mineral Rent(as % of GDP) in Ecuador in 1980 to that in 1981?
Your response must be concise. 3.62. What is the ratio of the Mineral Rent(as % of GDP) of Jamaica in 1980 to that in 1981?
Offer a terse response. 1. What is the ratio of the Mineral Rent(as % of GDP) in Namibia in 1980 to that in 1981?
Offer a very short reply. 1.49. What is the ratio of the Mineral Rent(as % of GDP) of Costa Rica in 1980 to that in 1982?
Offer a very short reply. 1.21. What is the ratio of the Mineral Rent(as % of GDP) of Ecuador in 1980 to that in 1982?
Ensure brevity in your answer.  10.73. What is the ratio of the Mineral Rent(as % of GDP) in Jamaica in 1980 to that in 1982?
Your response must be concise. 1.33. What is the ratio of the Mineral Rent(as % of GDP) in Namibia in 1980 to that in 1982?
Make the answer very short. 2.56. What is the ratio of the Mineral Rent(as % of GDP) of Costa Rica in 1980 to that in 1983?
Keep it short and to the point. 1.06. What is the ratio of the Mineral Rent(as % of GDP) of Ecuador in 1980 to that in 1983?
Ensure brevity in your answer.  20.96. What is the ratio of the Mineral Rent(as % of GDP) in Jamaica in 1980 to that in 1983?
Keep it short and to the point. 1.69. What is the ratio of the Mineral Rent(as % of GDP) in Namibia in 1980 to that in 1983?
Your answer should be very brief. 3.04. What is the ratio of the Mineral Rent(as % of GDP) in Costa Rica in 1980 to that in 1984?
Offer a terse response. 1.68. What is the ratio of the Mineral Rent(as % of GDP) of Ecuador in 1980 to that in 1984?
Keep it short and to the point. 0.08. What is the ratio of the Mineral Rent(as % of GDP) in Jamaica in 1980 to that in 1984?
Your answer should be very brief. 0.98. What is the ratio of the Mineral Rent(as % of GDP) of Namibia in 1980 to that in 1984?
Your answer should be very brief. 1.88. What is the ratio of the Mineral Rent(as % of GDP) of Costa Rica in 1980 to that in 1985?
Keep it short and to the point. 6.76. What is the ratio of the Mineral Rent(as % of GDP) in Ecuador in 1980 to that in 1985?
Offer a terse response. 0.13. What is the ratio of the Mineral Rent(as % of GDP) in Jamaica in 1980 to that in 1985?
Give a very brief answer. 1.27. What is the ratio of the Mineral Rent(as % of GDP) in Namibia in 1980 to that in 1985?
Provide a short and direct response. 1.4. What is the ratio of the Mineral Rent(as % of GDP) in Costa Rica in 1980 to that in 1986?
Keep it short and to the point. 4.62. What is the ratio of the Mineral Rent(as % of GDP) of Ecuador in 1980 to that in 1986?
Give a very brief answer. 0.09. What is the ratio of the Mineral Rent(as % of GDP) of Jamaica in 1980 to that in 1986?
Your answer should be compact. 1.68. What is the ratio of the Mineral Rent(as % of GDP) in Namibia in 1980 to that in 1986?
Keep it short and to the point. 7.02. What is the ratio of the Mineral Rent(as % of GDP) in Costa Rica in 1981 to that in 1982?
Ensure brevity in your answer.  1.32. What is the ratio of the Mineral Rent(as % of GDP) of Ecuador in 1981 to that in 1982?
Your response must be concise. 2.97. What is the ratio of the Mineral Rent(as % of GDP) of Jamaica in 1981 to that in 1982?
Provide a succinct answer. 1.32. What is the ratio of the Mineral Rent(as % of GDP) in Namibia in 1981 to that in 1982?
Provide a succinct answer. 1.72. What is the ratio of the Mineral Rent(as % of GDP) of Costa Rica in 1981 to that in 1983?
Offer a very short reply. 1.15. What is the ratio of the Mineral Rent(as % of GDP) of Ecuador in 1981 to that in 1983?
Give a very brief answer. 5.8. What is the ratio of the Mineral Rent(as % of GDP) of Jamaica in 1981 to that in 1983?
Provide a succinct answer. 1.68. What is the ratio of the Mineral Rent(as % of GDP) of Namibia in 1981 to that in 1983?
Ensure brevity in your answer.  2.04. What is the ratio of the Mineral Rent(as % of GDP) of Costa Rica in 1981 to that in 1984?
Make the answer very short. 1.84. What is the ratio of the Mineral Rent(as % of GDP) in Ecuador in 1981 to that in 1984?
Your answer should be very brief. 0.02. What is the ratio of the Mineral Rent(as % of GDP) in Jamaica in 1981 to that in 1984?
Give a very brief answer. 0.98. What is the ratio of the Mineral Rent(as % of GDP) in Namibia in 1981 to that in 1984?
Your answer should be compact. 1.26. What is the ratio of the Mineral Rent(as % of GDP) of Costa Rica in 1981 to that in 1985?
Your answer should be compact. 7.36. What is the ratio of the Mineral Rent(as % of GDP) in Ecuador in 1981 to that in 1985?
Your response must be concise. 0.04. What is the ratio of the Mineral Rent(as % of GDP) in Jamaica in 1981 to that in 1985?
Provide a short and direct response. 1.27. What is the ratio of the Mineral Rent(as % of GDP) in Namibia in 1981 to that in 1985?
Offer a very short reply. 0.94. What is the ratio of the Mineral Rent(as % of GDP) in Costa Rica in 1981 to that in 1986?
Offer a terse response. 5.03. What is the ratio of the Mineral Rent(as % of GDP) in Ecuador in 1981 to that in 1986?
Provide a succinct answer. 0.03. What is the ratio of the Mineral Rent(as % of GDP) of Jamaica in 1981 to that in 1986?
Your response must be concise. 1.67. What is the ratio of the Mineral Rent(as % of GDP) of Namibia in 1981 to that in 1986?
Give a very brief answer. 4.71. What is the ratio of the Mineral Rent(as % of GDP) of Costa Rica in 1982 to that in 1983?
Keep it short and to the point. 0.87. What is the ratio of the Mineral Rent(as % of GDP) in Ecuador in 1982 to that in 1983?
Give a very brief answer. 1.95. What is the ratio of the Mineral Rent(as % of GDP) in Jamaica in 1982 to that in 1983?
Make the answer very short. 1.28. What is the ratio of the Mineral Rent(as % of GDP) of Namibia in 1982 to that in 1983?
Your answer should be compact. 1.19. What is the ratio of the Mineral Rent(as % of GDP) of Costa Rica in 1982 to that in 1984?
Ensure brevity in your answer.  1.39. What is the ratio of the Mineral Rent(as % of GDP) of Ecuador in 1982 to that in 1984?
Provide a short and direct response. 0.01. What is the ratio of the Mineral Rent(as % of GDP) of Jamaica in 1982 to that in 1984?
Offer a terse response. 0.74. What is the ratio of the Mineral Rent(as % of GDP) of Namibia in 1982 to that in 1984?
Your answer should be compact. 0.73. What is the ratio of the Mineral Rent(as % of GDP) in Costa Rica in 1982 to that in 1985?
Offer a terse response. 5.56. What is the ratio of the Mineral Rent(as % of GDP) in Ecuador in 1982 to that in 1985?
Your answer should be very brief. 0.01. What is the ratio of the Mineral Rent(as % of GDP) of Jamaica in 1982 to that in 1985?
Make the answer very short. 0.96. What is the ratio of the Mineral Rent(as % of GDP) of Namibia in 1982 to that in 1985?
Give a very brief answer. 0.55. What is the ratio of the Mineral Rent(as % of GDP) in Costa Rica in 1982 to that in 1986?
Your answer should be compact. 3.8. What is the ratio of the Mineral Rent(as % of GDP) of Ecuador in 1982 to that in 1986?
Offer a very short reply. 0.01. What is the ratio of the Mineral Rent(as % of GDP) of Jamaica in 1982 to that in 1986?
Give a very brief answer. 1.27. What is the ratio of the Mineral Rent(as % of GDP) in Namibia in 1982 to that in 1986?
Offer a very short reply. 2.75. What is the ratio of the Mineral Rent(as % of GDP) of Costa Rica in 1983 to that in 1984?
Your answer should be compact. 1.59. What is the ratio of the Mineral Rent(as % of GDP) in Ecuador in 1983 to that in 1984?
Your response must be concise. 0. What is the ratio of the Mineral Rent(as % of GDP) of Jamaica in 1983 to that in 1984?
Your answer should be compact. 0.58. What is the ratio of the Mineral Rent(as % of GDP) in Namibia in 1983 to that in 1984?
Your answer should be compact. 0.62. What is the ratio of the Mineral Rent(as % of GDP) in Costa Rica in 1983 to that in 1985?
Your answer should be compact. 6.38. What is the ratio of the Mineral Rent(as % of GDP) of Ecuador in 1983 to that in 1985?
Keep it short and to the point. 0.01. What is the ratio of the Mineral Rent(as % of GDP) of Jamaica in 1983 to that in 1985?
Your answer should be compact. 0.75. What is the ratio of the Mineral Rent(as % of GDP) in Namibia in 1983 to that in 1985?
Your answer should be compact. 0.46. What is the ratio of the Mineral Rent(as % of GDP) of Costa Rica in 1983 to that in 1986?
Provide a short and direct response. 4.36. What is the ratio of the Mineral Rent(as % of GDP) of Ecuador in 1983 to that in 1986?
Your response must be concise. 0. What is the ratio of the Mineral Rent(as % of GDP) in Namibia in 1983 to that in 1986?
Make the answer very short. 2.31. What is the ratio of the Mineral Rent(as % of GDP) of Costa Rica in 1984 to that in 1985?
Provide a succinct answer. 4.01. What is the ratio of the Mineral Rent(as % of GDP) in Ecuador in 1984 to that in 1985?
Offer a terse response. 1.68. What is the ratio of the Mineral Rent(as % of GDP) of Jamaica in 1984 to that in 1985?
Give a very brief answer. 1.29. What is the ratio of the Mineral Rent(as % of GDP) of Namibia in 1984 to that in 1985?
Offer a terse response. 0.75. What is the ratio of the Mineral Rent(as % of GDP) in Costa Rica in 1984 to that in 1986?
Your answer should be very brief. 2.74. What is the ratio of the Mineral Rent(as % of GDP) in Ecuador in 1984 to that in 1986?
Ensure brevity in your answer.  1.19. What is the ratio of the Mineral Rent(as % of GDP) of Jamaica in 1984 to that in 1986?
Keep it short and to the point. 1.71. What is the ratio of the Mineral Rent(as % of GDP) in Namibia in 1984 to that in 1986?
Provide a short and direct response. 3.74. What is the ratio of the Mineral Rent(as % of GDP) in Costa Rica in 1985 to that in 1986?
Your answer should be compact. 0.68. What is the ratio of the Mineral Rent(as % of GDP) of Ecuador in 1985 to that in 1986?
Your answer should be compact. 0.71. What is the ratio of the Mineral Rent(as % of GDP) in Jamaica in 1985 to that in 1986?
Your response must be concise. 1.32. What is the ratio of the Mineral Rent(as % of GDP) in Namibia in 1985 to that in 1986?
Your answer should be compact. 5.01. What is the difference between the highest and the second highest Mineral Rent(as % of GDP) in Costa Rica?
Offer a very short reply. 0.01. What is the difference between the highest and the second highest Mineral Rent(as % of GDP) of Ecuador?
Keep it short and to the point. 0.02. What is the difference between the highest and the second highest Mineral Rent(as % of GDP) of Jamaica?
Offer a terse response. 0.17. What is the difference between the highest and the second highest Mineral Rent(as % of GDP) of Namibia?
Your answer should be very brief. 1.69. What is the difference between the highest and the lowest Mineral Rent(as % of GDP) of Costa Rica?
Offer a terse response. 0.11. What is the difference between the highest and the lowest Mineral Rent(as % of GDP) of Ecuador?
Your response must be concise. 0.15. What is the difference between the highest and the lowest Mineral Rent(as % of GDP) of Jamaica?
Offer a terse response. 4.55. What is the difference between the highest and the lowest Mineral Rent(as % of GDP) in Namibia?
Keep it short and to the point. 5.06. 